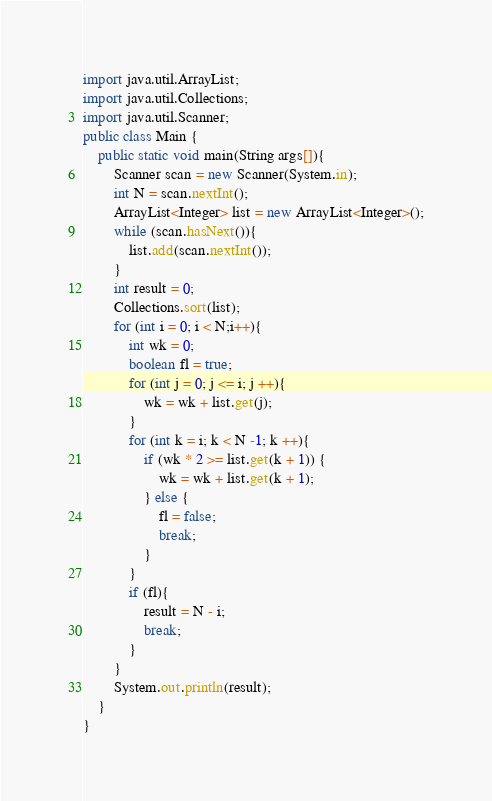Convert code to text. <code><loc_0><loc_0><loc_500><loc_500><_Java_>import java.util.ArrayList;
import java.util.Collections;
import java.util.Scanner;
public class Main {
	public static void main(String args[]){
		Scanner scan = new Scanner(System.in);
		int N = scan.nextInt();
		ArrayList<Integer> list = new ArrayList<Integer>();
		while (scan.hasNext()){
			list.add(scan.nextInt());
		}
		int result = 0;
		Collections.sort(list);
		for (int i = 0; i < N;i++){
			int wk = 0;
			boolean fl = true;
			for (int j = 0; j <= i; j ++){
				wk = wk + list.get(j);
			}
			for (int k = i; k < N -1; k ++){
				if (wk * 2 >= list.get(k + 1)) {
					wk = wk + list.get(k + 1);
				} else {
					fl = false;
					break;
				}
			}
			if (fl){
				result = N - i;
				break;
			}
		}
		System.out.println(result);
	}
}
</code> 